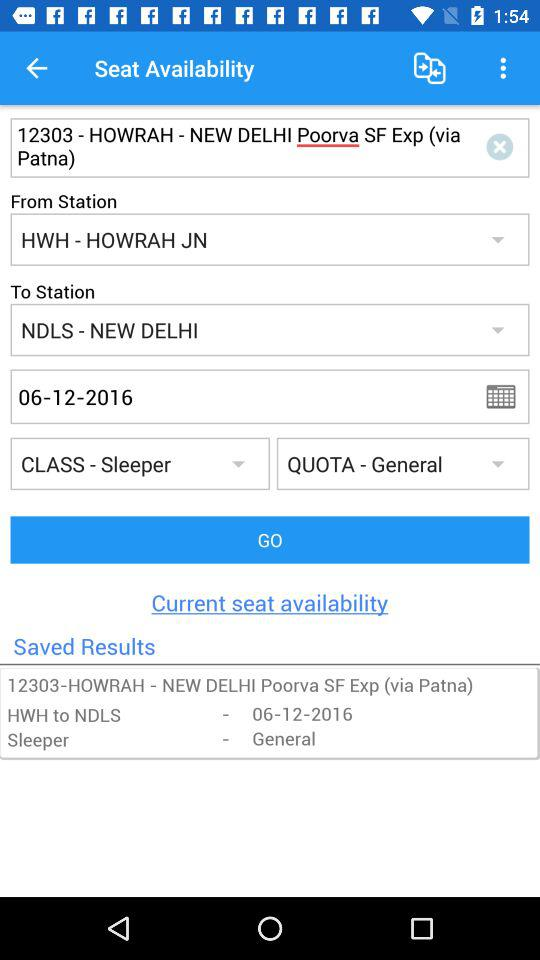What is the booking class? The booking class is sleeper. 